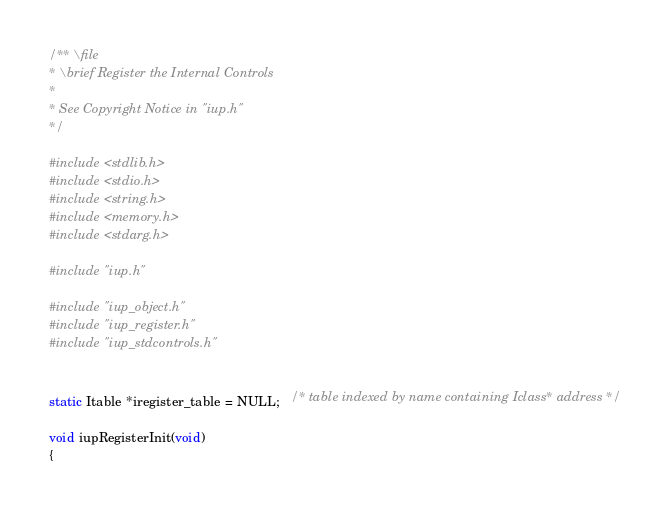<code> <loc_0><loc_0><loc_500><loc_500><_C_>/** \file
* \brief Register the Internal Controls
*
* See Copyright Notice in "iup.h"
*/

#include <stdlib.h>
#include <stdio.h>
#include <string.h>
#include <memory.h>
#include <stdarg.h>

#include "iup.h"

#include "iup_object.h"
#include "iup_register.h"
#include "iup_stdcontrols.h"


static Itable *iregister_table = NULL;   /* table indexed by name containing Iclass* address */

void iupRegisterInit(void)
{</code> 